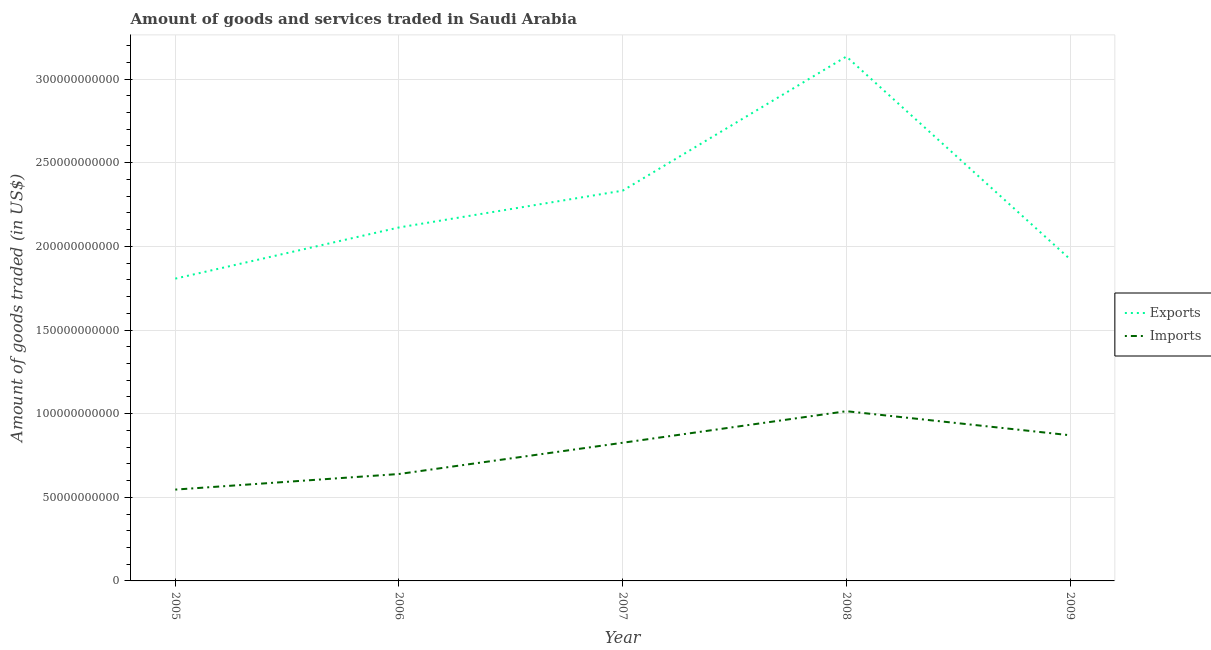Does the line corresponding to amount of goods imported intersect with the line corresponding to amount of goods exported?
Offer a terse response. No. What is the amount of goods imported in 2006?
Provide a short and direct response. 6.39e+1. Across all years, what is the maximum amount of goods exported?
Your answer should be very brief. 3.13e+11. Across all years, what is the minimum amount of goods imported?
Provide a short and direct response. 5.46e+1. In which year was the amount of goods imported minimum?
Make the answer very short. 2005. What is the total amount of goods exported in the graph?
Give a very brief answer. 1.13e+12. What is the difference between the amount of goods imported in 2005 and that in 2007?
Your response must be concise. -2.80e+1. What is the difference between the amount of goods exported in 2007 and the amount of goods imported in 2005?
Provide a short and direct response. 1.79e+11. What is the average amount of goods exported per year?
Provide a succinct answer. 2.26e+11. In the year 2008, what is the difference between the amount of goods imported and amount of goods exported?
Provide a short and direct response. -2.12e+11. What is the ratio of the amount of goods exported in 2005 to that in 2009?
Your response must be concise. 0.94. Is the amount of goods exported in 2006 less than that in 2008?
Provide a short and direct response. Yes. Is the difference between the amount of goods imported in 2007 and 2009 greater than the difference between the amount of goods exported in 2007 and 2009?
Your answer should be compact. No. What is the difference between the highest and the second highest amount of goods exported?
Ensure brevity in your answer.  8.02e+1. What is the difference between the highest and the lowest amount of goods exported?
Give a very brief answer. 1.33e+11. Is the sum of the amount of goods exported in 2005 and 2007 greater than the maximum amount of goods imported across all years?
Provide a succinct answer. Yes. Is the amount of goods imported strictly less than the amount of goods exported over the years?
Your response must be concise. Yes. How many lines are there?
Your response must be concise. 2. How many years are there in the graph?
Make the answer very short. 5. Are the values on the major ticks of Y-axis written in scientific E-notation?
Offer a terse response. No. Does the graph contain grids?
Your answer should be compact. Yes. Where does the legend appear in the graph?
Make the answer very short. Center right. How many legend labels are there?
Offer a terse response. 2. How are the legend labels stacked?
Give a very brief answer. Vertical. What is the title of the graph?
Your answer should be very brief. Amount of goods and services traded in Saudi Arabia. What is the label or title of the Y-axis?
Offer a very short reply. Amount of goods traded (in US$). What is the Amount of goods traded (in US$) in Exports in 2005?
Your answer should be compact. 1.81e+11. What is the Amount of goods traded (in US$) in Imports in 2005?
Provide a short and direct response. 5.46e+1. What is the Amount of goods traded (in US$) of Exports in 2006?
Your response must be concise. 2.11e+11. What is the Amount of goods traded (in US$) of Imports in 2006?
Give a very brief answer. 6.39e+1. What is the Amount of goods traded (in US$) of Exports in 2007?
Give a very brief answer. 2.33e+11. What is the Amount of goods traded (in US$) of Imports in 2007?
Provide a succinct answer. 8.26e+1. What is the Amount of goods traded (in US$) of Exports in 2008?
Your response must be concise. 3.13e+11. What is the Amount of goods traded (in US$) in Imports in 2008?
Your answer should be compact. 1.01e+11. What is the Amount of goods traded (in US$) of Exports in 2009?
Ensure brevity in your answer.  1.92e+11. What is the Amount of goods traded (in US$) of Imports in 2009?
Offer a terse response. 8.71e+1. Across all years, what is the maximum Amount of goods traded (in US$) of Exports?
Offer a terse response. 3.13e+11. Across all years, what is the maximum Amount of goods traded (in US$) of Imports?
Give a very brief answer. 1.01e+11. Across all years, what is the minimum Amount of goods traded (in US$) of Exports?
Your answer should be compact. 1.81e+11. Across all years, what is the minimum Amount of goods traded (in US$) in Imports?
Provide a succinct answer. 5.46e+1. What is the total Amount of goods traded (in US$) in Exports in the graph?
Your answer should be very brief. 1.13e+12. What is the total Amount of goods traded (in US$) in Imports in the graph?
Make the answer very short. 3.90e+11. What is the difference between the Amount of goods traded (in US$) in Exports in 2005 and that in 2006?
Your answer should be very brief. -3.06e+1. What is the difference between the Amount of goods traded (in US$) in Imports in 2005 and that in 2006?
Offer a very short reply. -9.32e+09. What is the difference between the Amount of goods traded (in US$) in Exports in 2005 and that in 2007?
Ensure brevity in your answer.  -5.26e+1. What is the difference between the Amount of goods traded (in US$) in Imports in 2005 and that in 2007?
Ensure brevity in your answer.  -2.80e+1. What is the difference between the Amount of goods traded (in US$) of Exports in 2005 and that in 2008?
Provide a succinct answer. -1.33e+11. What is the difference between the Amount of goods traded (in US$) in Imports in 2005 and that in 2008?
Offer a terse response. -4.69e+1. What is the difference between the Amount of goods traded (in US$) in Exports in 2005 and that in 2009?
Your answer should be very brief. -1.16e+1. What is the difference between the Amount of goods traded (in US$) in Imports in 2005 and that in 2009?
Provide a short and direct response. -3.25e+1. What is the difference between the Amount of goods traded (in US$) in Exports in 2006 and that in 2007?
Offer a terse response. -2.20e+1. What is the difference between the Amount of goods traded (in US$) in Imports in 2006 and that in 2007?
Keep it short and to the point. -1.87e+1. What is the difference between the Amount of goods traded (in US$) in Exports in 2006 and that in 2008?
Provide a succinct answer. -1.02e+11. What is the difference between the Amount of goods traded (in US$) of Imports in 2006 and that in 2008?
Provide a short and direct response. -3.75e+1. What is the difference between the Amount of goods traded (in US$) in Exports in 2006 and that in 2009?
Your answer should be compact. 1.90e+1. What is the difference between the Amount of goods traded (in US$) of Imports in 2006 and that in 2009?
Keep it short and to the point. -2.32e+1. What is the difference between the Amount of goods traded (in US$) of Exports in 2007 and that in 2008?
Offer a very short reply. -8.02e+1. What is the difference between the Amount of goods traded (in US$) in Imports in 2007 and that in 2008?
Make the answer very short. -1.89e+1. What is the difference between the Amount of goods traded (in US$) of Exports in 2007 and that in 2009?
Offer a very short reply. 4.10e+1. What is the difference between the Amount of goods traded (in US$) in Imports in 2007 and that in 2009?
Provide a short and direct response. -4.48e+09. What is the difference between the Amount of goods traded (in US$) of Exports in 2008 and that in 2009?
Make the answer very short. 1.21e+11. What is the difference between the Amount of goods traded (in US$) in Imports in 2008 and that in 2009?
Your answer should be very brief. 1.44e+1. What is the difference between the Amount of goods traded (in US$) of Exports in 2005 and the Amount of goods traded (in US$) of Imports in 2006?
Make the answer very short. 1.17e+11. What is the difference between the Amount of goods traded (in US$) of Exports in 2005 and the Amount of goods traded (in US$) of Imports in 2007?
Make the answer very short. 9.81e+1. What is the difference between the Amount of goods traded (in US$) in Exports in 2005 and the Amount of goods traded (in US$) in Imports in 2008?
Give a very brief answer. 7.93e+1. What is the difference between the Amount of goods traded (in US$) in Exports in 2005 and the Amount of goods traded (in US$) in Imports in 2009?
Your answer should be very brief. 9.36e+1. What is the difference between the Amount of goods traded (in US$) in Exports in 2006 and the Amount of goods traded (in US$) in Imports in 2007?
Your answer should be very brief. 1.29e+11. What is the difference between the Amount of goods traded (in US$) in Exports in 2006 and the Amount of goods traded (in US$) in Imports in 2008?
Your response must be concise. 1.10e+11. What is the difference between the Amount of goods traded (in US$) of Exports in 2006 and the Amount of goods traded (in US$) of Imports in 2009?
Your response must be concise. 1.24e+11. What is the difference between the Amount of goods traded (in US$) of Exports in 2007 and the Amount of goods traded (in US$) of Imports in 2008?
Offer a very short reply. 1.32e+11. What is the difference between the Amount of goods traded (in US$) in Exports in 2007 and the Amount of goods traded (in US$) in Imports in 2009?
Keep it short and to the point. 1.46e+11. What is the difference between the Amount of goods traded (in US$) in Exports in 2008 and the Amount of goods traded (in US$) in Imports in 2009?
Offer a very short reply. 2.26e+11. What is the average Amount of goods traded (in US$) in Exports per year?
Offer a very short reply. 2.26e+11. What is the average Amount of goods traded (in US$) in Imports per year?
Keep it short and to the point. 7.79e+1. In the year 2005, what is the difference between the Amount of goods traded (in US$) in Exports and Amount of goods traded (in US$) in Imports?
Ensure brevity in your answer.  1.26e+11. In the year 2006, what is the difference between the Amount of goods traded (in US$) of Exports and Amount of goods traded (in US$) of Imports?
Give a very brief answer. 1.47e+11. In the year 2007, what is the difference between the Amount of goods traded (in US$) of Exports and Amount of goods traded (in US$) of Imports?
Provide a short and direct response. 1.51e+11. In the year 2008, what is the difference between the Amount of goods traded (in US$) in Exports and Amount of goods traded (in US$) in Imports?
Keep it short and to the point. 2.12e+11. In the year 2009, what is the difference between the Amount of goods traded (in US$) of Exports and Amount of goods traded (in US$) of Imports?
Offer a terse response. 1.05e+11. What is the ratio of the Amount of goods traded (in US$) of Exports in 2005 to that in 2006?
Keep it short and to the point. 0.86. What is the ratio of the Amount of goods traded (in US$) of Imports in 2005 to that in 2006?
Your answer should be very brief. 0.85. What is the ratio of the Amount of goods traded (in US$) in Exports in 2005 to that in 2007?
Give a very brief answer. 0.77. What is the ratio of the Amount of goods traded (in US$) of Imports in 2005 to that in 2007?
Provide a short and direct response. 0.66. What is the ratio of the Amount of goods traded (in US$) in Exports in 2005 to that in 2008?
Offer a terse response. 0.58. What is the ratio of the Amount of goods traded (in US$) in Imports in 2005 to that in 2008?
Your answer should be compact. 0.54. What is the ratio of the Amount of goods traded (in US$) of Exports in 2005 to that in 2009?
Ensure brevity in your answer.  0.94. What is the ratio of the Amount of goods traded (in US$) in Imports in 2005 to that in 2009?
Your response must be concise. 0.63. What is the ratio of the Amount of goods traded (in US$) in Exports in 2006 to that in 2007?
Ensure brevity in your answer.  0.91. What is the ratio of the Amount of goods traded (in US$) in Imports in 2006 to that in 2007?
Make the answer very short. 0.77. What is the ratio of the Amount of goods traded (in US$) of Exports in 2006 to that in 2008?
Keep it short and to the point. 0.67. What is the ratio of the Amount of goods traded (in US$) in Imports in 2006 to that in 2008?
Provide a short and direct response. 0.63. What is the ratio of the Amount of goods traded (in US$) of Exports in 2006 to that in 2009?
Your answer should be compact. 1.1. What is the ratio of the Amount of goods traded (in US$) of Imports in 2006 to that in 2009?
Offer a terse response. 0.73. What is the ratio of the Amount of goods traded (in US$) of Exports in 2007 to that in 2008?
Provide a short and direct response. 0.74. What is the ratio of the Amount of goods traded (in US$) in Imports in 2007 to that in 2008?
Your answer should be compact. 0.81. What is the ratio of the Amount of goods traded (in US$) in Exports in 2007 to that in 2009?
Ensure brevity in your answer.  1.21. What is the ratio of the Amount of goods traded (in US$) in Imports in 2007 to that in 2009?
Give a very brief answer. 0.95. What is the ratio of the Amount of goods traded (in US$) in Exports in 2008 to that in 2009?
Provide a succinct answer. 1.63. What is the ratio of the Amount of goods traded (in US$) of Imports in 2008 to that in 2009?
Give a very brief answer. 1.17. What is the difference between the highest and the second highest Amount of goods traded (in US$) of Exports?
Offer a terse response. 8.02e+1. What is the difference between the highest and the second highest Amount of goods traded (in US$) of Imports?
Keep it short and to the point. 1.44e+1. What is the difference between the highest and the lowest Amount of goods traded (in US$) in Exports?
Your answer should be very brief. 1.33e+11. What is the difference between the highest and the lowest Amount of goods traded (in US$) in Imports?
Your answer should be compact. 4.69e+1. 